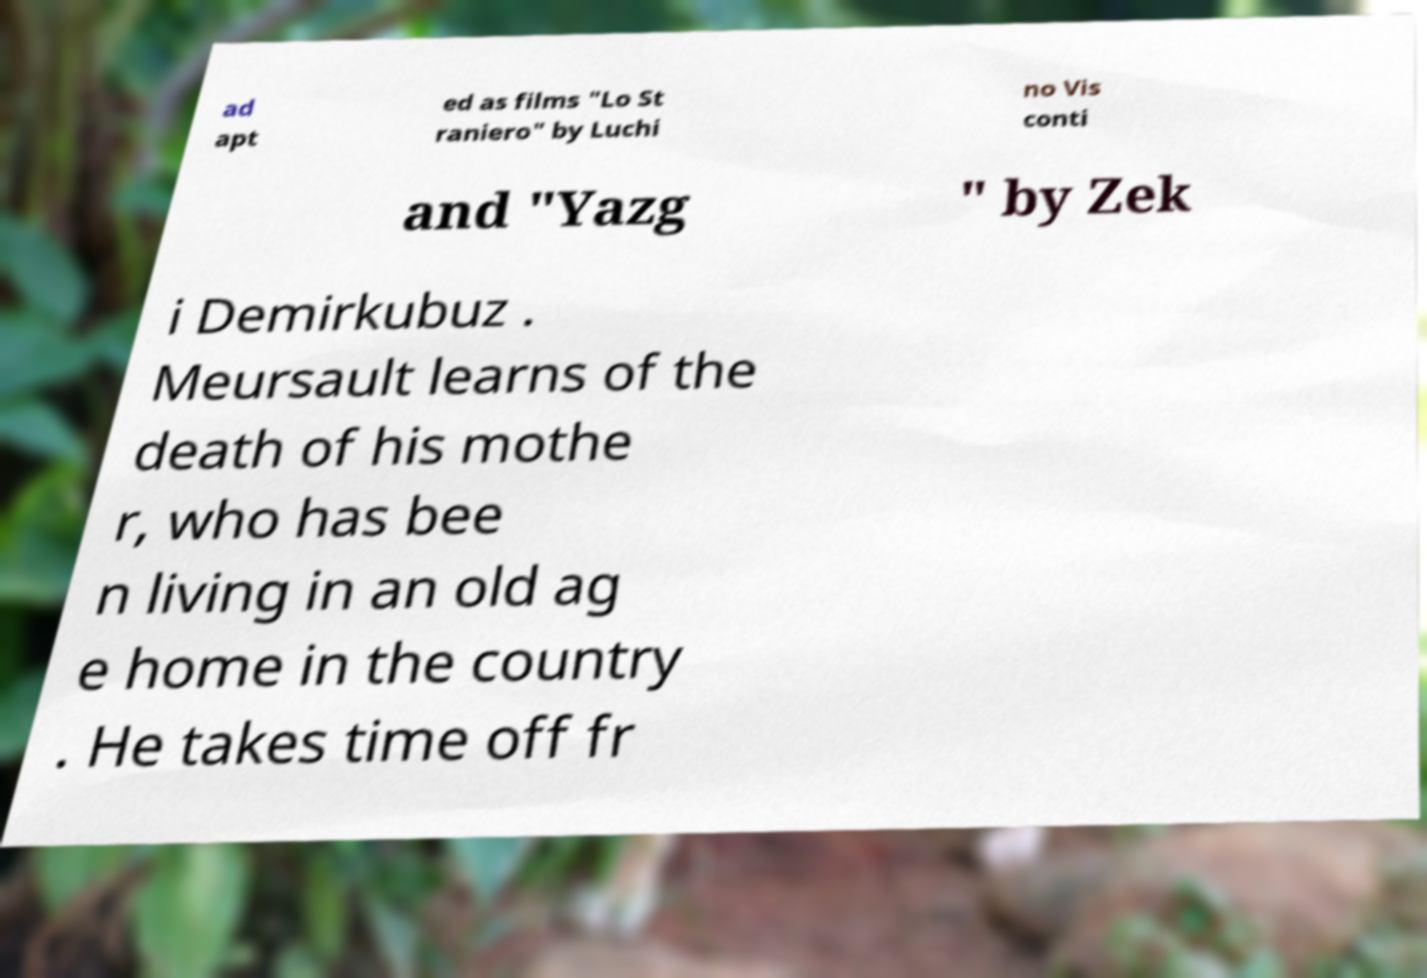What messages or text are displayed in this image? I need them in a readable, typed format. ad apt ed as films "Lo St raniero" by Luchi no Vis conti and "Yazg " by Zek i Demirkubuz . Meursault learns of the death of his mothe r, who has bee n living in an old ag e home in the country . He takes time off fr 